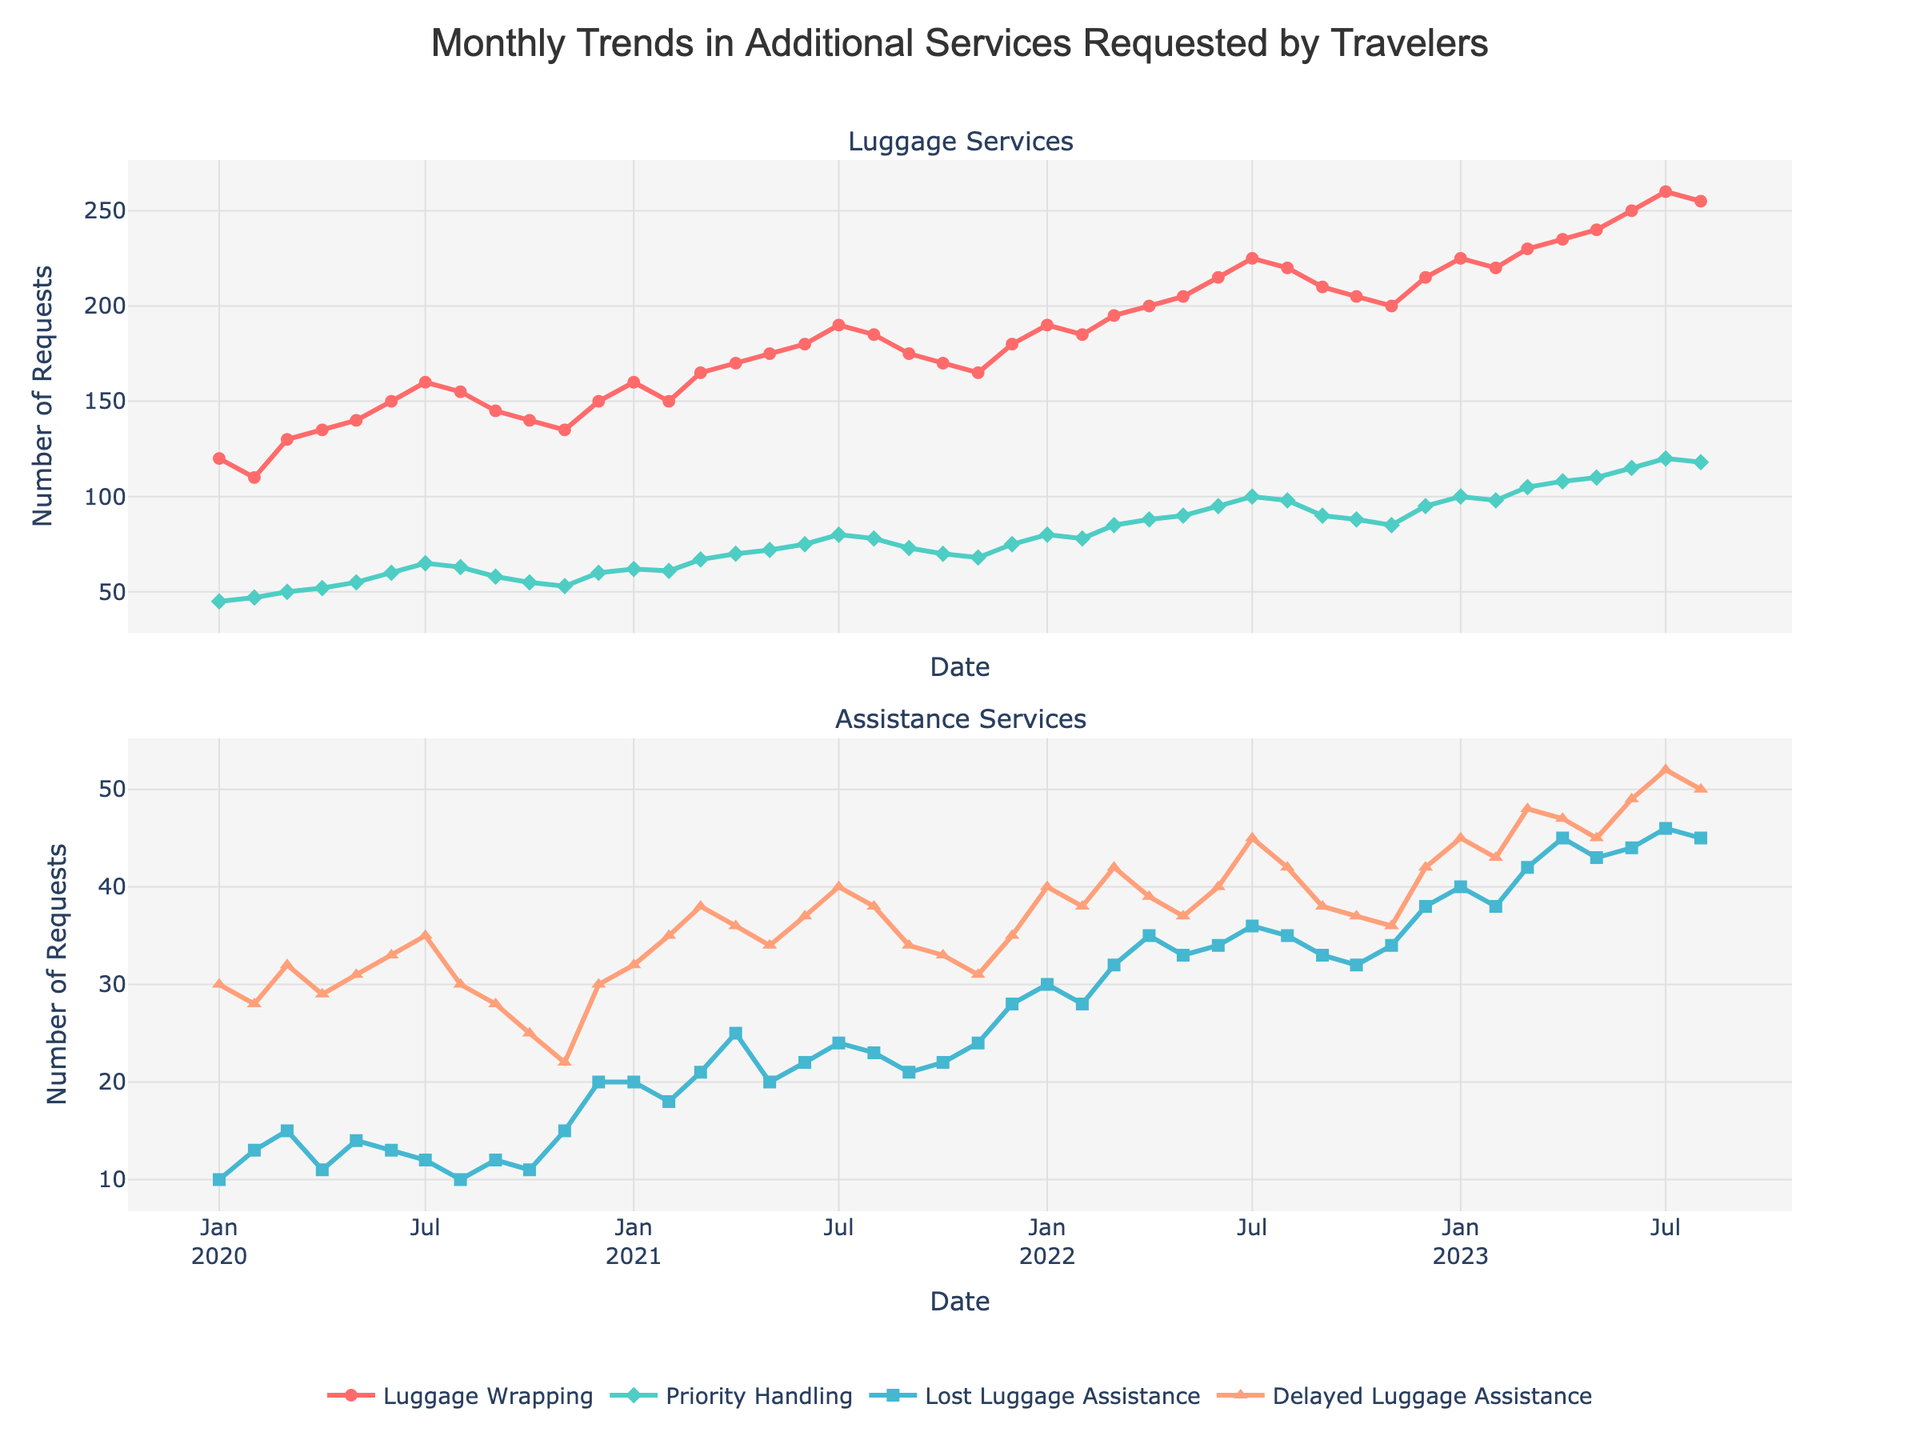How many data points are plotted for each service? The x-axis represents 44 months, from January 2020 to August 2023. Since there are four services represented (Luggage Wrapping, Priority Handling, Lost Luggage Assistance, and Delayed Luggage Assistance), each line has 44 points.
Answer: 44 During which month and year was the number of Luggage Wrapping requests the highest? The highest point on the Luggage Wrapping line occurs at July 2023, where the count reaches 260 requests.
Answer: July 2023 How do Priority Handling requests compare between January 2022 and January 2023? In January 2022, Priority Handling requests were at 80, while in January 2023, they increased to 100. By comparing these values, we see an increase.
Answer: 100 > 80 What is the average number of Lost Luggage Assistance requests in 2021? The numbers of Lost Luggage Assistance requests in 2021 are: 20, 18, 21, 25, 20, 22, 24, 23, 21, 22, 24, 28. Summing these gives 268. Since there are 12 months, the average is 268/12.
Answer: 22.33 What trend can be observed in Delayed Luggage Assistance requests from January 2020 to August 2023? From January 2020 (30) to August 2023 (50), there is a generally increasing trend in Delayed Luggage Assistance requests, although there are some fluctuations.
Answer: Increasing Which service saw the most significant increase from January 2020 to January 2023? Comparing the values for each service from January 2020 to January 2023, the increases are: Luggage Wrapping (120 to 225), Priority Handling (45 to 100), Lost Luggage Assistance (10 to 40), and Delayed Luggage Assistance (30 to 45). The largest increase is seen in Luggage Wrapping (120 to 225).
Answer: Luggage Wrapping What is the difference in the number of Delayed Luggage Assistance requests between December 2022 and June 2023? In December 2022, Delayed Luggage Assistance requests were 42, whereas in June 2023, they were 49. The difference is 49 - 42.
Answer: 7 